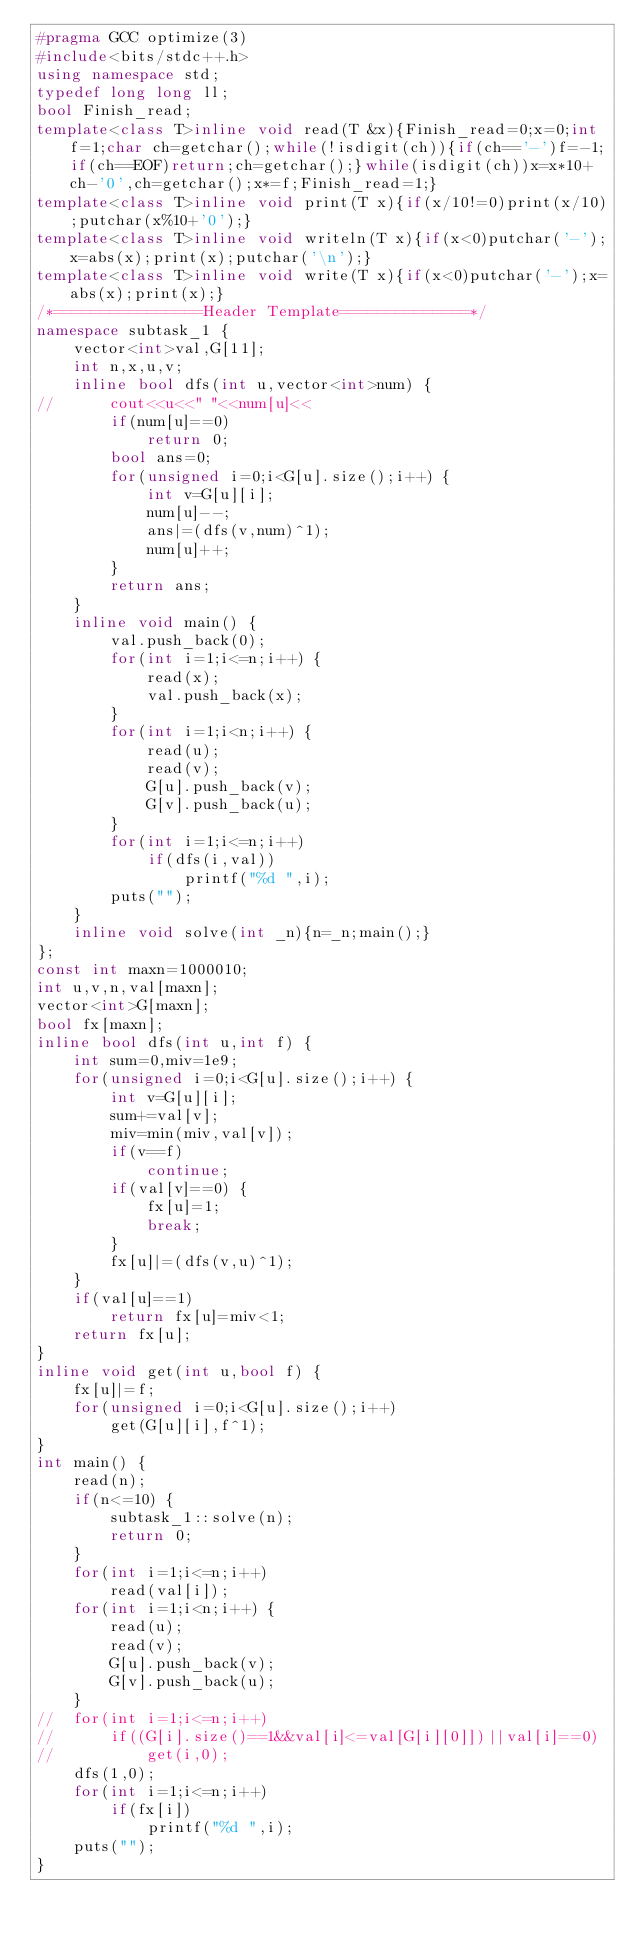<code> <loc_0><loc_0><loc_500><loc_500><_C++_>#pragma GCC optimize(3)
#include<bits/stdc++.h>
using namespace std;
typedef long long ll;
bool Finish_read;
template<class T>inline void read(T &x){Finish_read=0;x=0;int f=1;char ch=getchar();while(!isdigit(ch)){if(ch=='-')f=-1;if(ch==EOF)return;ch=getchar();}while(isdigit(ch))x=x*10+ch-'0',ch=getchar();x*=f;Finish_read=1;}
template<class T>inline void print(T x){if(x/10!=0)print(x/10);putchar(x%10+'0');}
template<class T>inline void writeln(T x){if(x<0)putchar('-');x=abs(x);print(x);putchar('\n');}
template<class T>inline void write(T x){if(x<0)putchar('-');x=abs(x);print(x);}
/*================Header Template==============*/
namespace subtask_1 {
	vector<int>val,G[11];
	int n,x,u,v;
	inline bool dfs(int u,vector<int>num) {
//		cout<<u<<" "<<num[u]<<
		if(num[u]==0)
			return 0;
		bool ans=0;
		for(unsigned i=0;i<G[u].size();i++) {
			int v=G[u][i];
			num[u]--;
			ans|=(dfs(v,num)^1);
			num[u]++;
		}
		return ans;
	}
	inline void main() {
		val.push_back(0);
		for(int i=1;i<=n;i++) {
			read(x);
			val.push_back(x);
		}
		for(int i=1;i<n;i++) {
			read(u);
			read(v);
			G[u].push_back(v);
			G[v].push_back(u);
		}
		for(int i=1;i<=n;i++)
			if(dfs(i,val))
				printf("%d ",i);
		puts("");
	}
	inline void solve(int _n){n=_n;main();}
};
const int maxn=1000010;
int u,v,n,val[maxn];
vector<int>G[maxn];
bool fx[maxn];
inline bool dfs(int u,int f) {
	int sum=0,miv=1e9;
	for(unsigned i=0;i<G[u].size();i++) {
		int v=G[u][i];
		sum+=val[v];
		miv=min(miv,val[v]);
		if(v==f)
			continue;
		if(val[v]==0) {
			fx[u]=1;
			break;
		}
		fx[u]|=(dfs(v,u)^1);
	}
	if(val[u]==1)
		return fx[u]=miv<1;
	return fx[u];
}
inline void get(int u,bool f) {
	fx[u]|=f;
	for(unsigned i=0;i<G[u].size();i++)
		get(G[u][i],f^1);
}
int main() {
	read(n);
	if(n<=10) {
		subtask_1::solve(n);
		return 0;
	}
	for(int i=1;i<=n;i++)
		read(val[i]);
	for(int i=1;i<n;i++) {
		read(u);
		read(v);
		G[u].push_back(v);
		G[v].push_back(u);
	}
//	for(int i=1;i<=n;i++)
//		if((G[i].size()==1&&val[i]<=val[G[i][0]])||val[i]==0)
//			get(i,0); 
	dfs(1,0);
	for(int i=1;i<=n;i++)
		if(fx[i])
			printf("%d ",i);
	puts("");
}</code> 